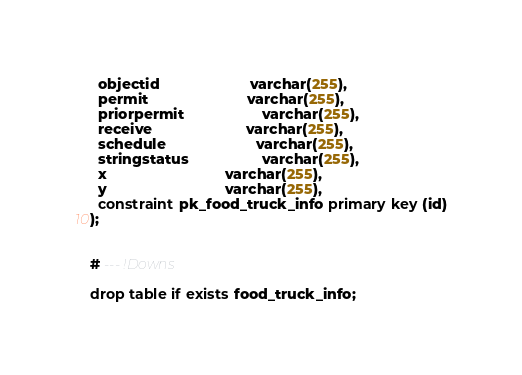<code> <loc_0><loc_0><loc_500><loc_500><_SQL_>  objectid                      varchar(255),
  permit                        varchar(255),
  priorpermit                   varchar(255),
  receive                       varchar(255),
  schedule                      varchar(255),
  stringstatus                  varchar(255),
  x                             varchar(255),
  y                             varchar(255),
  constraint pk_food_truck_info primary key (id)
);


# --- !Downs

drop table if exists food_truck_info;

</code> 